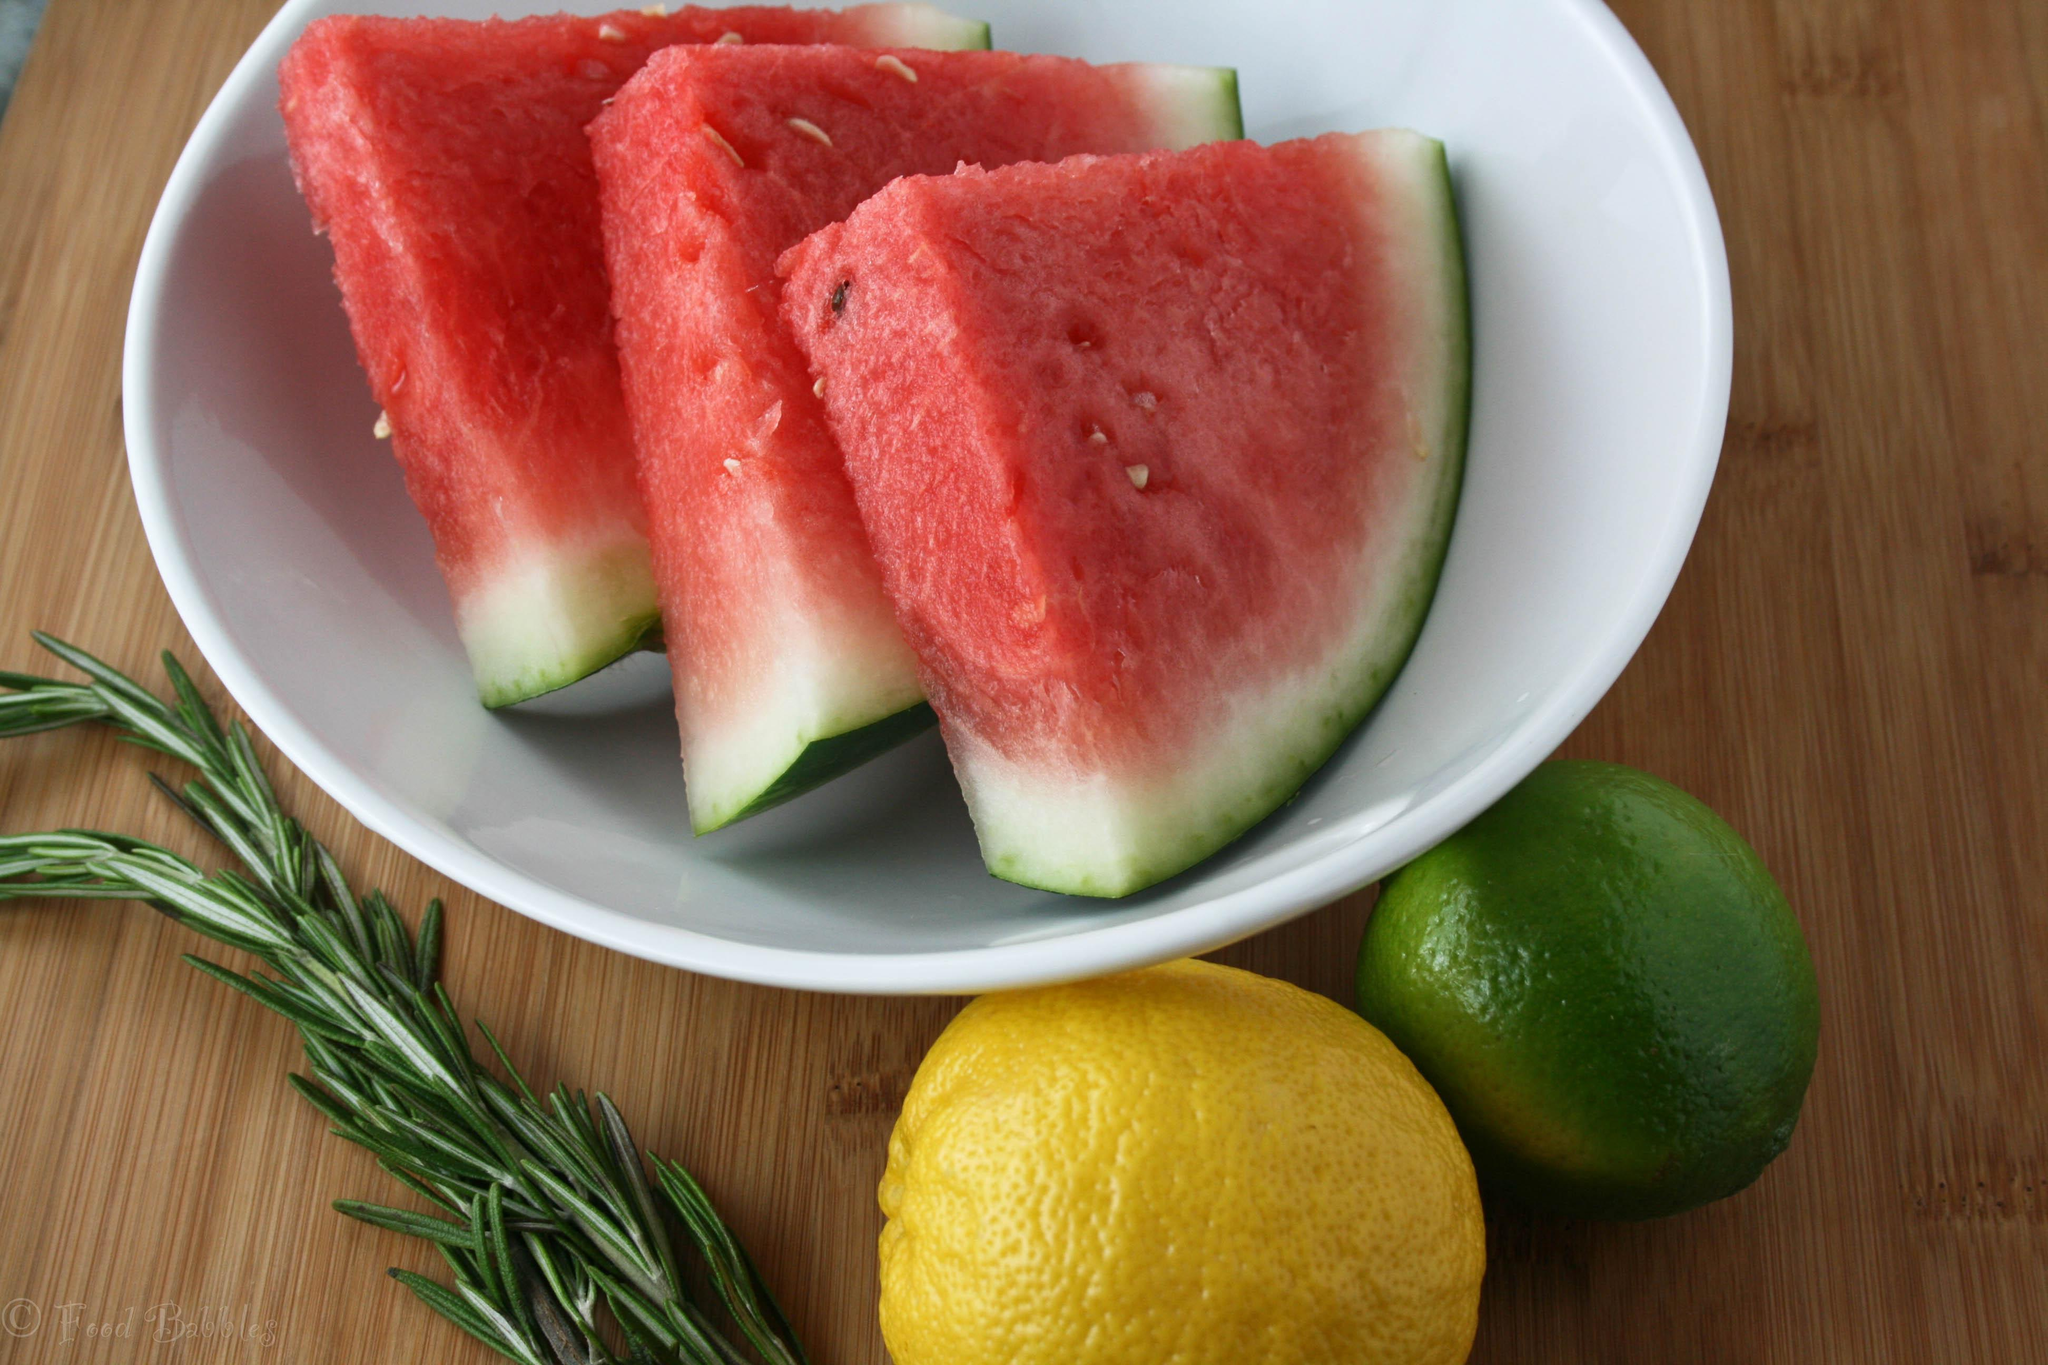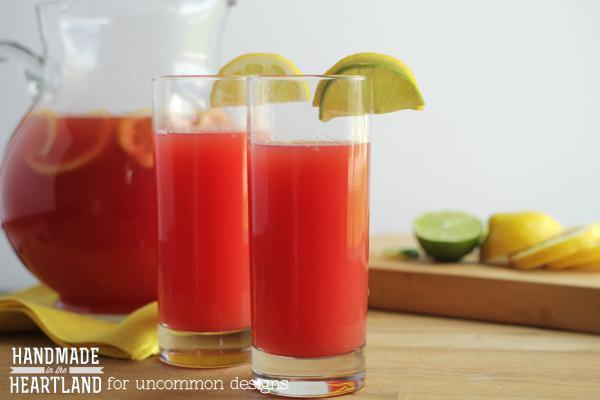The first image is the image on the left, the second image is the image on the right. Assess this claim about the two images: "In one image, multiple watermelon wedges have green rind and white area next to the red fruit.". Correct or not? Answer yes or no. Yes. The first image is the image on the left, the second image is the image on the right. Examine the images to the left and right. Is the description "One image shows fruit in a white bowl." accurate? Answer yes or no. Yes. 